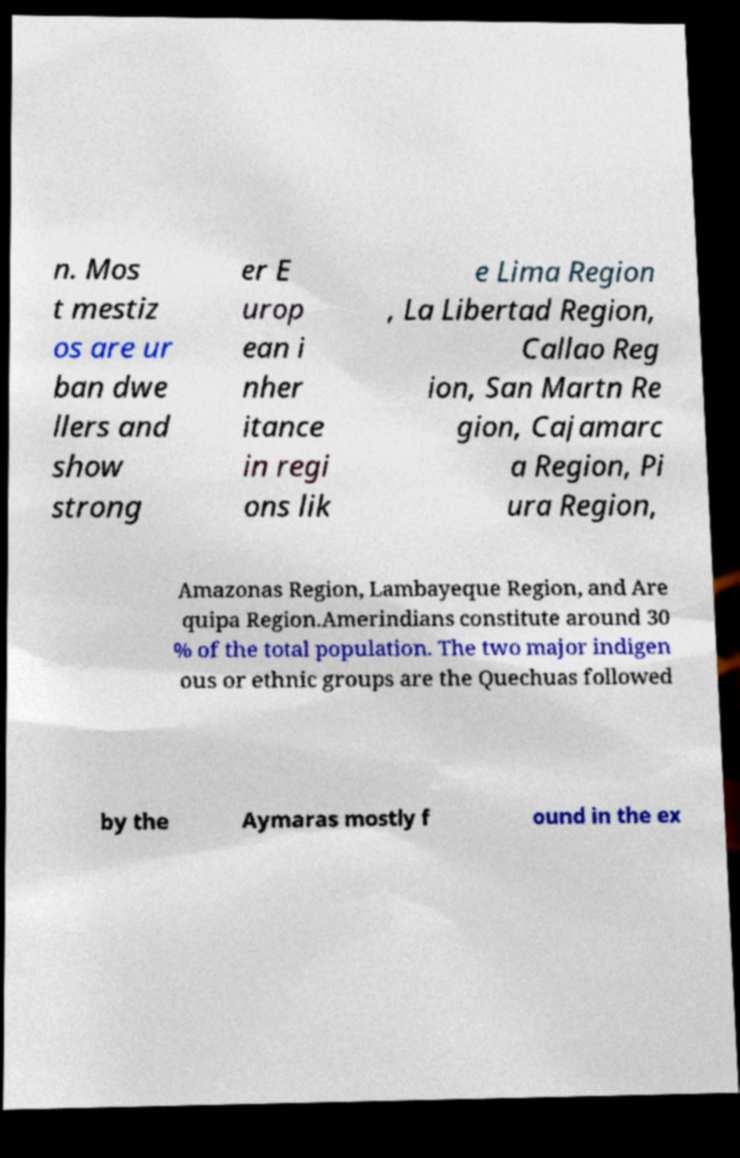Please read and relay the text visible in this image. What does it say? n. Mos t mestiz os are ur ban dwe llers and show strong er E urop ean i nher itance in regi ons lik e Lima Region , La Libertad Region, Callao Reg ion, San Martn Re gion, Cajamarc a Region, Pi ura Region, Amazonas Region, Lambayeque Region, and Are quipa Region.Amerindians constitute around 30 % of the total population. The two major indigen ous or ethnic groups are the Quechuas followed by the Aymaras mostly f ound in the ex 